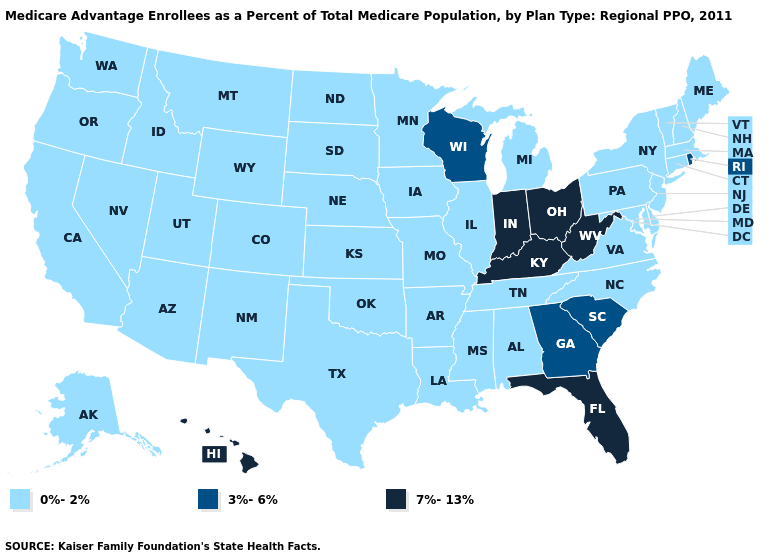Name the states that have a value in the range 7%-13%?
Give a very brief answer. Florida, Hawaii, Indiana, Kentucky, Ohio, West Virginia. What is the highest value in the USA?
Write a very short answer. 7%-13%. Does the map have missing data?
Short answer required. No. Which states have the lowest value in the USA?
Concise answer only. Alaska, Alabama, Arkansas, Arizona, California, Colorado, Connecticut, Delaware, Iowa, Idaho, Illinois, Kansas, Louisiana, Massachusetts, Maryland, Maine, Michigan, Minnesota, Missouri, Mississippi, Montana, North Carolina, North Dakota, Nebraska, New Hampshire, New Jersey, New Mexico, Nevada, New York, Oklahoma, Oregon, Pennsylvania, South Dakota, Tennessee, Texas, Utah, Virginia, Vermont, Washington, Wyoming. Does the first symbol in the legend represent the smallest category?
Give a very brief answer. Yes. Does Indiana have a lower value than Washington?
Answer briefly. No. Does Alabama have the lowest value in the South?
Keep it brief. Yes. Does West Virginia have the highest value in the USA?
Keep it brief. Yes. Does Missouri have a lower value than Mississippi?
Concise answer only. No. Does Georgia have the lowest value in the USA?
Give a very brief answer. No. What is the lowest value in the USA?
Keep it brief. 0%-2%. What is the value of South Dakota?
Write a very short answer. 0%-2%. Does Michigan have the lowest value in the USA?
Concise answer only. Yes. 